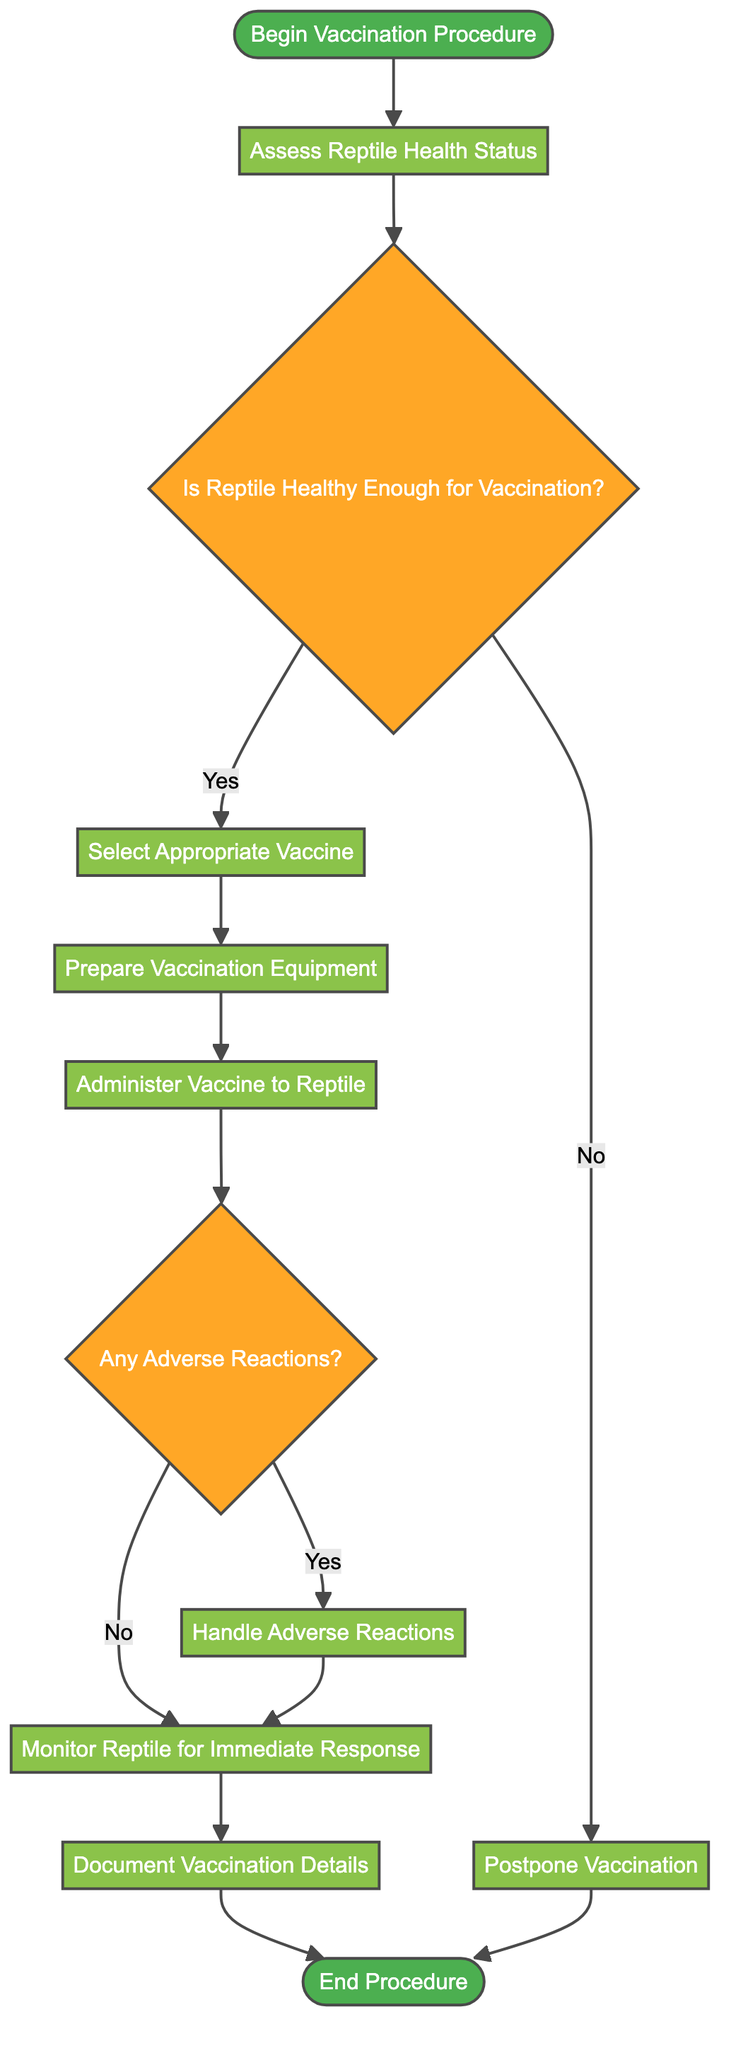What is the first action in the vaccination procedure? The first action in the vaccination process, as indicated in the diagram, is to "Assess Reptile Health Status." This is the first step after the starting node.
Answer: Assess Reptile Health Status How many decision nodes are present in the diagram? The diagram features two decision nodes, labeled "Is Reptile Healthy Enough for Vaccination?" and "Any Adverse Reactions?" These nodes guide the flow based on specific conditions.
Answer: 2 What happens if the reptile is not healthy enough for vaccination? If the reptile is not healthy enough for vaccination, the path leads to the action labeled "Postpone Vaccination," indicating that vaccination should not proceed under those circumstances.
Answer: Postpone Vaccination What precedes the action of administering the vaccine? Before administering the vaccine, the steps "Select Appropriate Vaccine" and "Prepare Vaccination Equipment" must be completed sequentially. Both actions are necessary prerequisites for the vaccine administration.
Answer: Prepare Vaccination Equipment If adverse reactions are present, what is the next step? Upon determining that there are adverse reactions after the vaccine is administered, the next step is to "Handle Adverse Reactions," indicating immediate action is required in response to those reactions.
Answer: Handle Adverse Reactions What is the last action before completing the vaccination procedure? The last action in the process before completing the procedure is to "Document Vaccination Details," ensuring all relevant information about the vaccination is recorded.
Answer: Document Vaccination Details What is the condition checked after administering the vaccine? The condition checked immediately after administering the vaccine is whether there are "Any Adverse Reactions?" This decision determines the subsequent action.
Answer: Any Adverse Reactions? 